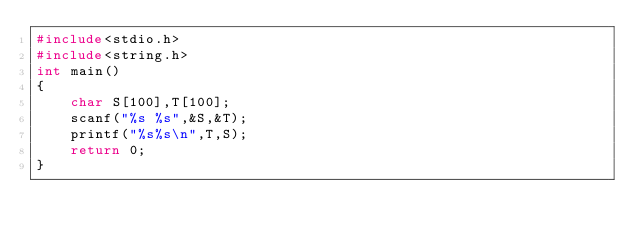<code> <loc_0><loc_0><loc_500><loc_500><_C_>#include<stdio.h>
#include<string.h>
int main()
{
    char S[100],T[100];
    scanf("%s %s",&S,&T);
    printf("%s%s\n",T,S);
    return 0;
}</code> 